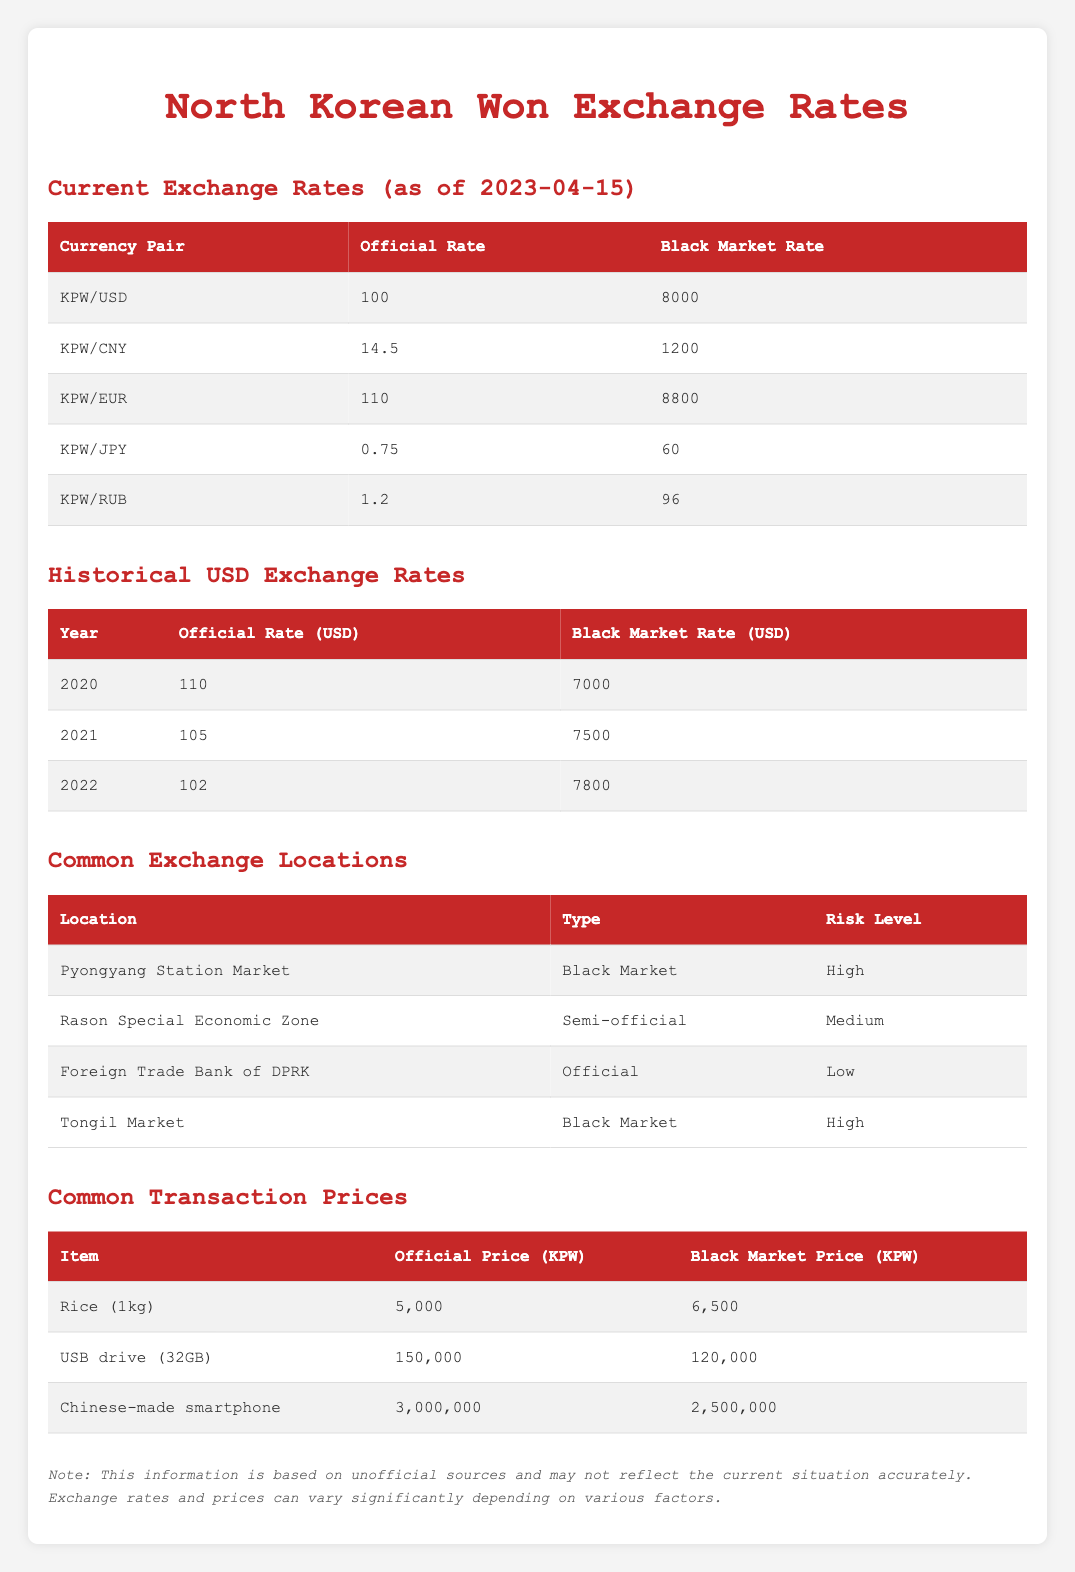What is the official exchange rate for KPW/USD? The table provides the exchange rates, and for KPW/USD, the official rate is listed as 100.
Answer: 100 What is the black market rate for KPW/CNY? Looking at the table, the black market rate for KPW/CNY is specified as 1200.
Answer: 1200 Is the official exchange rate for KPW/EUR higher than for KPW/USD? The official rate for KPW/EUR is 110 and for KPW/USD is 100. Since 110 is greater than 100, the statement is true.
Answer: Yes What is the difference between the official rate and black market rate for KPW/USD? The official rate for KPW/USD is 100 and the black market rate is 8000. The difference is calculated as 8000 - 100 = 7900.
Answer: 7900 What were the black market rates for USD from 2020 to 2022? The historical data shows black market rates for USD for each year: 2020 was 7000, 2021 was 7500, and 2022 was 7800.
Answer: 7000, 7500, 7800 Which currency pair has the greatest disparity between its official and black market rates? Looking at the differences: KPW/USD has 7900, KPW/EUR has 8690 (8800 - 110), KPW/CNY has 1185 (1200 - 14.5), KPW/JPY has 59.25, and KPW/RUB has 94.8. The greatest disparity is for KPW/EUR at 8690.
Answer: KPW/EUR Is Tongil Market a semi-official exchange location? The types of the exchange locations are listed; Tongil Market is marked as a black market, which is not semi-official.
Answer: No What is the combined average of the official exchange rates for KPW against USD, CNY, and EUR? The official rates are 100 (USD), 14.5 (CNY), and 110 (EUR). The combined average is (100 + 14.5 + 110) / 3 = 74.83.
Answer: 74.83 What is the risk level of the Foreign Trade Bank of DPRK compared to Pyongyang Station Market? The Foreign Trade Bank of DPRK has a low risk level, while Pyongyang Station Market has a high risk level. The comparison shows that the Foreign Trade Bank is less risky.
Answer: Less risky 